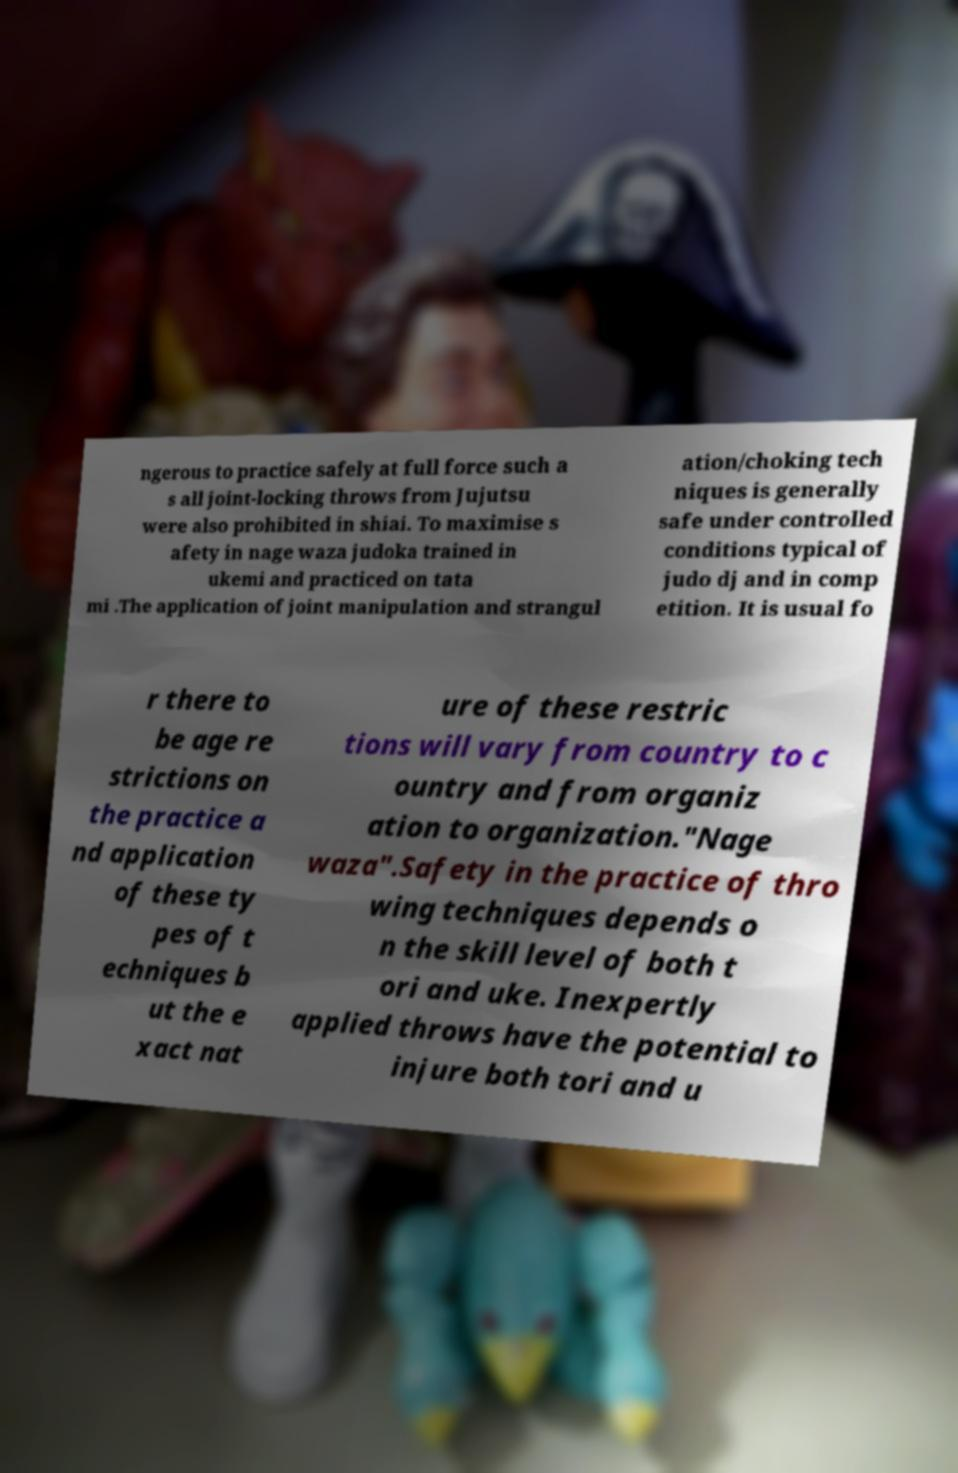I need the written content from this picture converted into text. Can you do that? ngerous to practice safely at full force such a s all joint-locking throws from Jujutsu were also prohibited in shiai. To maximise s afety in nage waza judoka trained in ukemi and practiced on tata mi .The application of joint manipulation and strangul ation/choking tech niques is generally safe under controlled conditions typical of judo dj and in comp etition. It is usual fo r there to be age re strictions on the practice a nd application of these ty pes of t echniques b ut the e xact nat ure of these restric tions will vary from country to c ountry and from organiz ation to organization."Nage waza".Safety in the practice of thro wing techniques depends o n the skill level of both t ori and uke. Inexpertly applied throws have the potential to injure both tori and u 